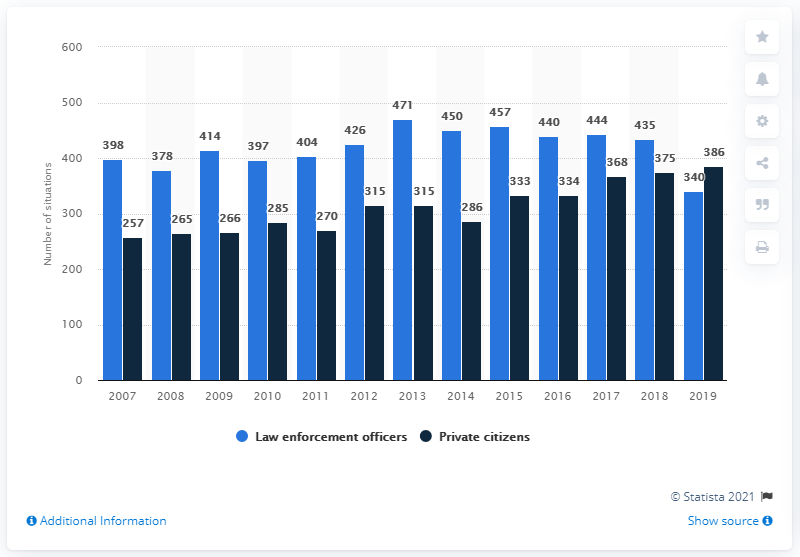Give some essential details in this illustration. According to data, in 2014 the disparity between the number of justifiable homicides committed by law enforcement officers and private citizens was the largest. There were 340 justifiable homicides committed by law enforcement officers in 2019 In 2019, the number of justifiable homicides by private citizens exceeded that of law enforcement officers. 